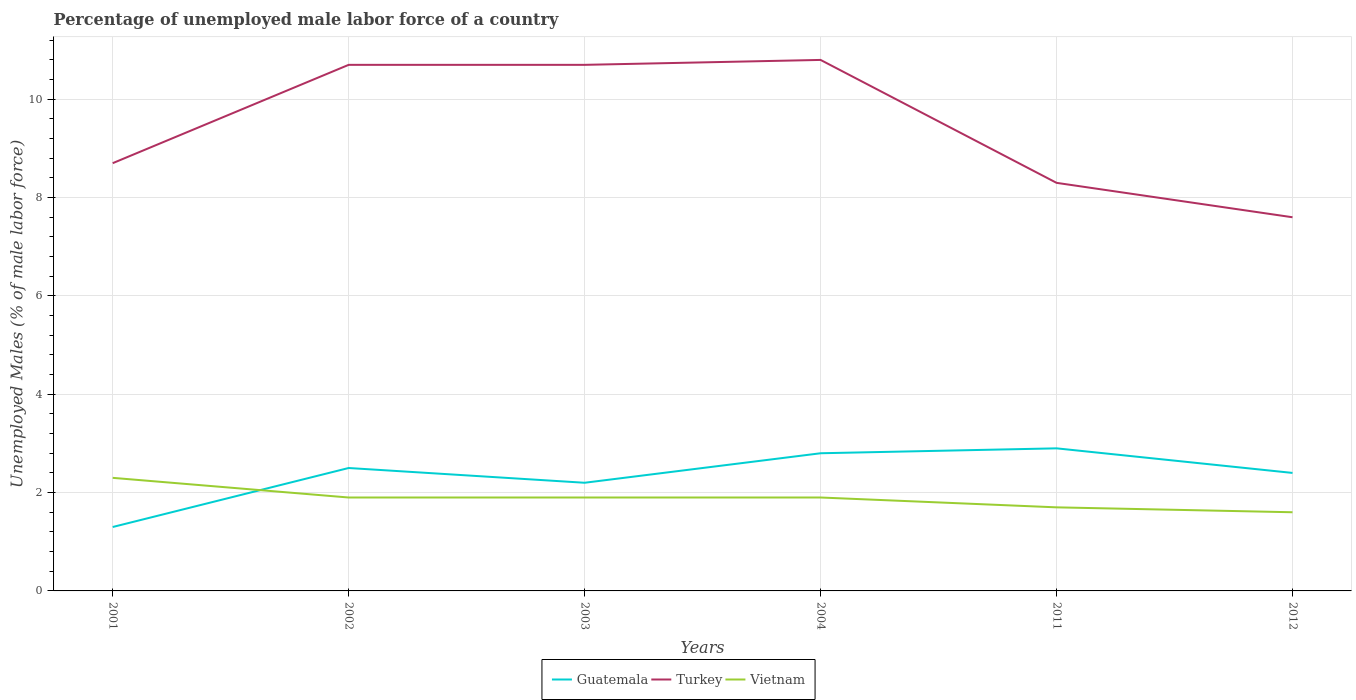How many different coloured lines are there?
Your answer should be compact. 3. Is the number of lines equal to the number of legend labels?
Your answer should be compact. Yes. Across all years, what is the maximum percentage of unemployed male labor force in Turkey?
Your answer should be very brief. 7.6. What is the total percentage of unemployed male labor force in Guatemala in the graph?
Offer a terse response. -0.1. What is the difference between the highest and the second highest percentage of unemployed male labor force in Vietnam?
Ensure brevity in your answer.  0.7. Is the percentage of unemployed male labor force in Guatemala strictly greater than the percentage of unemployed male labor force in Turkey over the years?
Give a very brief answer. Yes. How many lines are there?
Offer a very short reply. 3. What is the difference between two consecutive major ticks on the Y-axis?
Provide a short and direct response. 2. Are the values on the major ticks of Y-axis written in scientific E-notation?
Ensure brevity in your answer.  No. Does the graph contain any zero values?
Your answer should be compact. No. Does the graph contain grids?
Give a very brief answer. Yes. How many legend labels are there?
Keep it short and to the point. 3. How are the legend labels stacked?
Your answer should be very brief. Horizontal. What is the title of the graph?
Offer a very short reply. Percentage of unemployed male labor force of a country. Does "Qatar" appear as one of the legend labels in the graph?
Your answer should be compact. No. What is the label or title of the X-axis?
Your response must be concise. Years. What is the label or title of the Y-axis?
Keep it short and to the point. Unemployed Males (% of male labor force). What is the Unemployed Males (% of male labor force) of Guatemala in 2001?
Offer a terse response. 1.3. What is the Unemployed Males (% of male labor force) in Turkey in 2001?
Give a very brief answer. 8.7. What is the Unemployed Males (% of male labor force) of Vietnam in 2001?
Your response must be concise. 2.3. What is the Unemployed Males (% of male labor force) of Turkey in 2002?
Keep it short and to the point. 10.7. What is the Unemployed Males (% of male labor force) of Vietnam in 2002?
Keep it short and to the point. 1.9. What is the Unemployed Males (% of male labor force) of Guatemala in 2003?
Your response must be concise. 2.2. What is the Unemployed Males (% of male labor force) in Turkey in 2003?
Your response must be concise. 10.7. What is the Unemployed Males (% of male labor force) in Vietnam in 2003?
Give a very brief answer. 1.9. What is the Unemployed Males (% of male labor force) of Guatemala in 2004?
Provide a succinct answer. 2.8. What is the Unemployed Males (% of male labor force) of Turkey in 2004?
Make the answer very short. 10.8. What is the Unemployed Males (% of male labor force) of Vietnam in 2004?
Offer a terse response. 1.9. What is the Unemployed Males (% of male labor force) in Guatemala in 2011?
Provide a succinct answer. 2.9. What is the Unemployed Males (% of male labor force) of Turkey in 2011?
Your response must be concise. 8.3. What is the Unemployed Males (% of male labor force) in Vietnam in 2011?
Your answer should be compact. 1.7. What is the Unemployed Males (% of male labor force) of Guatemala in 2012?
Ensure brevity in your answer.  2.4. What is the Unemployed Males (% of male labor force) of Turkey in 2012?
Offer a very short reply. 7.6. What is the Unemployed Males (% of male labor force) in Vietnam in 2012?
Your response must be concise. 1.6. Across all years, what is the maximum Unemployed Males (% of male labor force) of Guatemala?
Your response must be concise. 2.9. Across all years, what is the maximum Unemployed Males (% of male labor force) of Turkey?
Your answer should be very brief. 10.8. Across all years, what is the maximum Unemployed Males (% of male labor force) of Vietnam?
Your answer should be compact. 2.3. Across all years, what is the minimum Unemployed Males (% of male labor force) in Guatemala?
Offer a very short reply. 1.3. Across all years, what is the minimum Unemployed Males (% of male labor force) in Turkey?
Your response must be concise. 7.6. Across all years, what is the minimum Unemployed Males (% of male labor force) of Vietnam?
Provide a succinct answer. 1.6. What is the total Unemployed Males (% of male labor force) in Turkey in the graph?
Offer a very short reply. 56.8. What is the difference between the Unemployed Males (% of male labor force) of Turkey in 2001 and that in 2002?
Make the answer very short. -2. What is the difference between the Unemployed Males (% of male labor force) in Vietnam in 2001 and that in 2003?
Provide a succinct answer. 0.4. What is the difference between the Unemployed Males (% of male labor force) of Turkey in 2001 and that in 2004?
Your answer should be compact. -2.1. What is the difference between the Unemployed Males (% of male labor force) of Turkey in 2001 and that in 2011?
Your answer should be very brief. 0.4. What is the difference between the Unemployed Males (% of male labor force) in Turkey in 2001 and that in 2012?
Your response must be concise. 1.1. What is the difference between the Unemployed Males (% of male labor force) of Guatemala in 2002 and that in 2003?
Your answer should be very brief. 0.3. What is the difference between the Unemployed Males (% of male labor force) of Turkey in 2002 and that in 2003?
Your answer should be compact. 0. What is the difference between the Unemployed Males (% of male labor force) of Guatemala in 2002 and that in 2004?
Provide a succinct answer. -0.3. What is the difference between the Unemployed Males (% of male labor force) in Vietnam in 2002 and that in 2004?
Offer a terse response. 0. What is the difference between the Unemployed Males (% of male labor force) of Turkey in 2002 and that in 2011?
Offer a terse response. 2.4. What is the difference between the Unemployed Males (% of male labor force) of Vietnam in 2002 and that in 2011?
Your answer should be compact. 0.2. What is the difference between the Unemployed Males (% of male labor force) in Turkey in 2002 and that in 2012?
Ensure brevity in your answer.  3.1. What is the difference between the Unemployed Males (% of male labor force) of Vietnam in 2002 and that in 2012?
Make the answer very short. 0.3. What is the difference between the Unemployed Males (% of male labor force) in Guatemala in 2003 and that in 2004?
Ensure brevity in your answer.  -0.6. What is the difference between the Unemployed Males (% of male labor force) of Turkey in 2003 and that in 2004?
Your response must be concise. -0.1. What is the difference between the Unemployed Males (% of male labor force) of Vietnam in 2003 and that in 2004?
Offer a very short reply. 0. What is the difference between the Unemployed Males (% of male labor force) in Guatemala in 2003 and that in 2011?
Your answer should be compact. -0.7. What is the difference between the Unemployed Males (% of male labor force) in Vietnam in 2003 and that in 2011?
Keep it short and to the point. 0.2. What is the difference between the Unemployed Males (% of male labor force) in Guatemala in 2003 and that in 2012?
Make the answer very short. -0.2. What is the difference between the Unemployed Males (% of male labor force) of Turkey in 2003 and that in 2012?
Provide a short and direct response. 3.1. What is the difference between the Unemployed Males (% of male labor force) in Vietnam in 2003 and that in 2012?
Provide a succinct answer. 0.3. What is the difference between the Unemployed Males (% of male labor force) in Guatemala in 2004 and that in 2011?
Ensure brevity in your answer.  -0.1. What is the difference between the Unemployed Males (% of male labor force) in Turkey in 2004 and that in 2011?
Offer a very short reply. 2.5. What is the difference between the Unemployed Males (% of male labor force) of Guatemala in 2004 and that in 2012?
Provide a succinct answer. 0.4. What is the difference between the Unemployed Males (% of male labor force) in Turkey in 2004 and that in 2012?
Your answer should be very brief. 3.2. What is the difference between the Unemployed Males (% of male labor force) in Vietnam in 2004 and that in 2012?
Your response must be concise. 0.3. What is the difference between the Unemployed Males (% of male labor force) of Vietnam in 2011 and that in 2012?
Give a very brief answer. 0.1. What is the difference between the Unemployed Males (% of male labor force) in Guatemala in 2001 and the Unemployed Males (% of male labor force) in Turkey in 2002?
Keep it short and to the point. -9.4. What is the difference between the Unemployed Males (% of male labor force) of Turkey in 2001 and the Unemployed Males (% of male labor force) of Vietnam in 2002?
Provide a short and direct response. 6.8. What is the difference between the Unemployed Males (% of male labor force) of Guatemala in 2001 and the Unemployed Males (% of male labor force) of Turkey in 2003?
Offer a very short reply. -9.4. What is the difference between the Unemployed Males (% of male labor force) of Guatemala in 2001 and the Unemployed Males (% of male labor force) of Vietnam in 2003?
Ensure brevity in your answer.  -0.6. What is the difference between the Unemployed Males (% of male labor force) in Turkey in 2001 and the Unemployed Males (% of male labor force) in Vietnam in 2003?
Make the answer very short. 6.8. What is the difference between the Unemployed Males (% of male labor force) of Guatemala in 2001 and the Unemployed Males (% of male labor force) of Turkey in 2011?
Offer a terse response. -7. What is the difference between the Unemployed Males (% of male labor force) in Guatemala in 2001 and the Unemployed Males (% of male labor force) in Vietnam in 2011?
Ensure brevity in your answer.  -0.4. What is the difference between the Unemployed Males (% of male labor force) of Turkey in 2001 and the Unemployed Males (% of male labor force) of Vietnam in 2011?
Provide a succinct answer. 7. What is the difference between the Unemployed Males (% of male labor force) of Guatemala in 2001 and the Unemployed Males (% of male labor force) of Vietnam in 2012?
Ensure brevity in your answer.  -0.3. What is the difference between the Unemployed Males (% of male labor force) of Turkey in 2002 and the Unemployed Males (% of male labor force) of Vietnam in 2003?
Give a very brief answer. 8.8. What is the difference between the Unemployed Males (% of male labor force) in Guatemala in 2002 and the Unemployed Males (% of male labor force) in Vietnam in 2004?
Your response must be concise. 0.6. What is the difference between the Unemployed Males (% of male labor force) in Turkey in 2002 and the Unemployed Males (% of male labor force) in Vietnam in 2004?
Your answer should be compact. 8.8. What is the difference between the Unemployed Males (% of male labor force) of Guatemala in 2002 and the Unemployed Males (% of male labor force) of Turkey in 2011?
Your response must be concise. -5.8. What is the difference between the Unemployed Males (% of male labor force) of Guatemala in 2002 and the Unemployed Males (% of male labor force) of Vietnam in 2011?
Give a very brief answer. 0.8. What is the difference between the Unemployed Males (% of male labor force) in Guatemala in 2002 and the Unemployed Males (% of male labor force) in Turkey in 2012?
Give a very brief answer. -5.1. What is the difference between the Unemployed Males (% of male labor force) of Guatemala in 2003 and the Unemployed Males (% of male labor force) of Turkey in 2004?
Offer a very short reply. -8.6. What is the difference between the Unemployed Males (% of male labor force) in Turkey in 2003 and the Unemployed Males (% of male labor force) in Vietnam in 2011?
Your answer should be compact. 9. What is the difference between the Unemployed Males (% of male labor force) in Guatemala in 2003 and the Unemployed Males (% of male labor force) in Turkey in 2012?
Your answer should be compact. -5.4. What is the difference between the Unemployed Males (% of male labor force) in Turkey in 2003 and the Unemployed Males (% of male labor force) in Vietnam in 2012?
Give a very brief answer. 9.1. What is the difference between the Unemployed Males (% of male labor force) in Guatemala in 2004 and the Unemployed Males (% of male labor force) in Turkey in 2011?
Your response must be concise. -5.5. What is the difference between the Unemployed Males (% of male labor force) of Turkey in 2004 and the Unemployed Males (% of male labor force) of Vietnam in 2012?
Offer a very short reply. 9.2. What is the difference between the Unemployed Males (% of male labor force) of Guatemala in 2011 and the Unemployed Males (% of male labor force) of Turkey in 2012?
Offer a very short reply. -4.7. What is the difference between the Unemployed Males (% of male labor force) of Guatemala in 2011 and the Unemployed Males (% of male labor force) of Vietnam in 2012?
Your response must be concise. 1.3. What is the difference between the Unemployed Males (% of male labor force) of Turkey in 2011 and the Unemployed Males (% of male labor force) of Vietnam in 2012?
Keep it short and to the point. 6.7. What is the average Unemployed Males (% of male labor force) in Guatemala per year?
Offer a terse response. 2.35. What is the average Unemployed Males (% of male labor force) of Turkey per year?
Your response must be concise. 9.47. What is the average Unemployed Males (% of male labor force) of Vietnam per year?
Keep it short and to the point. 1.88. In the year 2001, what is the difference between the Unemployed Males (% of male labor force) in Guatemala and Unemployed Males (% of male labor force) in Turkey?
Make the answer very short. -7.4. In the year 2002, what is the difference between the Unemployed Males (% of male labor force) in Turkey and Unemployed Males (% of male labor force) in Vietnam?
Offer a very short reply. 8.8. In the year 2003, what is the difference between the Unemployed Males (% of male labor force) in Guatemala and Unemployed Males (% of male labor force) in Vietnam?
Keep it short and to the point. 0.3. In the year 2004, what is the difference between the Unemployed Males (% of male labor force) in Guatemala and Unemployed Males (% of male labor force) in Turkey?
Provide a short and direct response. -8. In the year 2004, what is the difference between the Unemployed Males (% of male labor force) in Guatemala and Unemployed Males (% of male labor force) in Vietnam?
Your answer should be very brief. 0.9. In the year 2011, what is the difference between the Unemployed Males (% of male labor force) in Turkey and Unemployed Males (% of male labor force) in Vietnam?
Your answer should be compact. 6.6. In the year 2012, what is the difference between the Unemployed Males (% of male labor force) in Guatemala and Unemployed Males (% of male labor force) in Turkey?
Offer a very short reply. -5.2. What is the ratio of the Unemployed Males (% of male labor force) of Guatemala in 2001 to that in 2002?
Provide a succinct answer. 0.52. What is the ratio of the Unemployed Males (% of male labor force) in Turkey in 2001 to that in 2002?
Offer a very short reply. 0.81. What is the ratio of the Unemployed Males (% of male labor force) of Vietnam in 2001 to that in 2002?
Offer a very short reply. 1.21. What is the ratio of the Unemployed Males (% of male labor force) in Guatemala in 2001 to that in 2003?
Your response must be concise. 0.59. What is the ratio of the Unemployed Males (% of male labor force) of Turkey in 2001 to that in 2003?
Your answer should be very brief. 0.81. What is the ratio of the Unemployed Males (% of male labor force) in Vietnam in 2001 to that in 2003?
Give a very brief answer. 1.21. What is the ratio of the Unemployed Males (% of male labor force) of Guatemala in 2001 to that in 2004?
Give a very brief answer. 0.46. What is the ratio of the Unemployed Males (% of male labor force) in Turkey in 2001 to that in 2004?
Your answer should be very brief. 0.81. What is the ratio of the Unemployed Males (% of male labor force) of Vietnam in 2001 to that in 2004?
Your response must be concise. 1.21. What is the ratio of the Unemployed Males (% of male labor force) of Guatemala in 2001 to that in 2011?
Keep it short and to the point. 0.45. What is the ratio of the Unemployed Males (% of male labor force) of Turkey in 2001 to that in 2011?
Your answer should be very brief. 1.05. What is the ratio of the Unemployed Males (% of male labor force) of Vietnam in 2001 to that in 2011?
Give a very brief answer. 1.35. What is the ratio of the Unemployed Males (% of male labor force) of Guatemala in 2001 to that in 2012?
Offer a terse response. 0.54. What is the ratio of the Unemployed Males (% of male labor force) in Turkey in 2001 to that in 2012?
Give a very brief answer. 1.14. What is the ratio of the Unemployed Males (% of male labor force) in Vietnam in 2001 to that in 2012?
Ensure brevity in your answer.  1.44. What is the ratio of the Unemployed Males (% of male labor force) in Guatemala in 2002 to that in 2003?
Give a very brief answer. 1.14. What is the ratio of the Unemployed Males (% of male labor force) in Guatemala in 2002 to that in 2004?
Provide a short and direct response. 0.89. What is the ratio of the Unemployed Males (% of male labor force) in Turkey in 2002 to that in 2004?
Provide a short and direct response. 0.99. What is the ratio of the Unemployed Males (% of male labor force) in Guatemala in 2002 to that in 2011?
Keep it short and to the point. 0.86. What is the ratio of the Unemployed Males (% of male labor force) in Turkey in 2002 to that in 2011?
Make the answer very short. 1.29. What is the ratio of the Unemployed Males (% of male labor force) in Vietnam in 2002 to that in 2011?
Your answer should be very brief. 1.12. What is the ratio of the Unemployed Males (% of male labor force) in Guatemala in 2002 to that in 2012?
Ensure brevity in your answer.  1.04. What is the ratio of the Unemployed Males (% of male labor force) of Turkey in 2002 to that in 2012?
Your answer should be very brief. 1.41. What is the ratio of the Unemployed Males (% of male labor force) of Vietnam in 2002 to that in 2012?
Offer a terse response. 1.19. What is the ratio of the Unemployed Males (% of male labor force) of Guatemala in 2003 to that in 2004?
Provide a succinct answer. 0.79. What is the ratio of the Unemployed Males (% of male labor force) of Guatemala in 2003 to that in 2011?
Provide a succinct answer. 0.76. What is the ratio of the Unemployed Males (% of male labor force) of Turkey in 2003 to that in 2011?
Your response must be concise. 1.29. What is the ratio of the Unemployed Males (% of male labor force) of Vietnam in 2003 to that in 2011?
Offer a terse response. 1.12. What is the ratio of the Unemployed Males (% of male labor force) of Guatemala in 2003 to that in 2012?
Ensure brevity in your answer.  0.92. What is the ratio of the Unemployed Males (% of male labor force) of Turkey in 2003 to that in 2012?
Your answer should be compact. 1.41. What is the ratio of the Unemployed Males (% of male labor force) of Vietnam in 2003 to that in 2012?
Your answer should be compact. 1.19. What is the ratio of the Unemployed Males (% of male labor force) in Guatemala in 2004 to that in 2011?
Ensure brevity in your answer.  0.97. What is the ratio of the Unemployed Males (% of male labor force) of Turkey in 2004 to that in 2011?
Offer a very short reply. 1.3. What is the ratio of the Unemployed Males (% of male labor force) of Vietnam in 2004 to that in 2011?
Offer a very short reply. 1.12. What is the ratio of the Unemployed Males (% of male labor force) of Guatemala in 2004 to that in 2012?
Provide a succinct answer. 1.17. What is the ratio of the Unemployed Males (% of male labor force) in Turkey in 2004 to that in 2012?
Offer a terse response. 1.42. What is the ratio of the Unemployed Males (% of male labor force) in Vietnam in 2004 to that in 2012?
Your answer should be compact. 1.19. What is the ratio of the Unemployed Males (% of male labor force) of Guatemala in 2011 to that in 2012?
Your answer should be very brief. 1.21. What is the ratio of the Unemployed Males (% of male labor force) of Turkey in 2011 to that in 2012?
Your answer should be compact. 1.09. What is the difference between the highest and the second highest Unemployed Males (% of male labor force) in Turkey?
Your answer should be very brief. 0.1. What is the difference between the highest and the second highest Unemployed Males (% of male labor force) of Vietnam?
Make the answer very short. 0.4. 